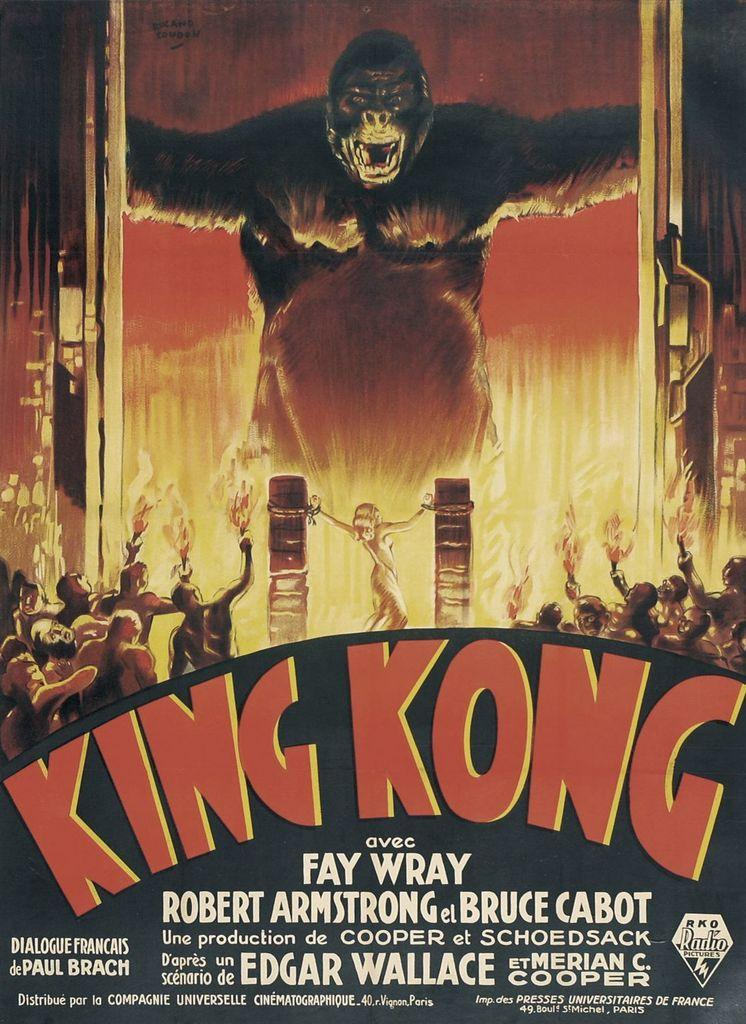<image>
Present a compact description of the photo's key features. A poster for King Kong starring Fay Wray. 